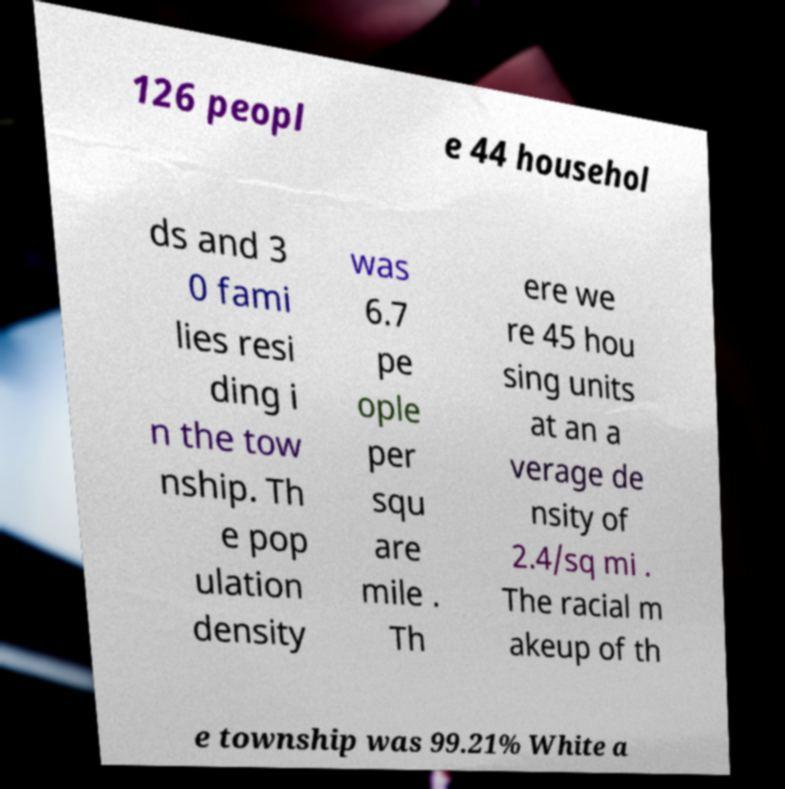Can you accurately transcribe the text from the provided image for me? 126 peopl e 44 househol ds and 3 0 fami lies resi ding i n the tow nship. Th e pop ulation density was 6.7 pe ople per squ are mile . Th ere we re 45 hou sing units at an a verage de nsity of 2.4/sq mi . The racial m akeup of th e township was 99.21% White a 